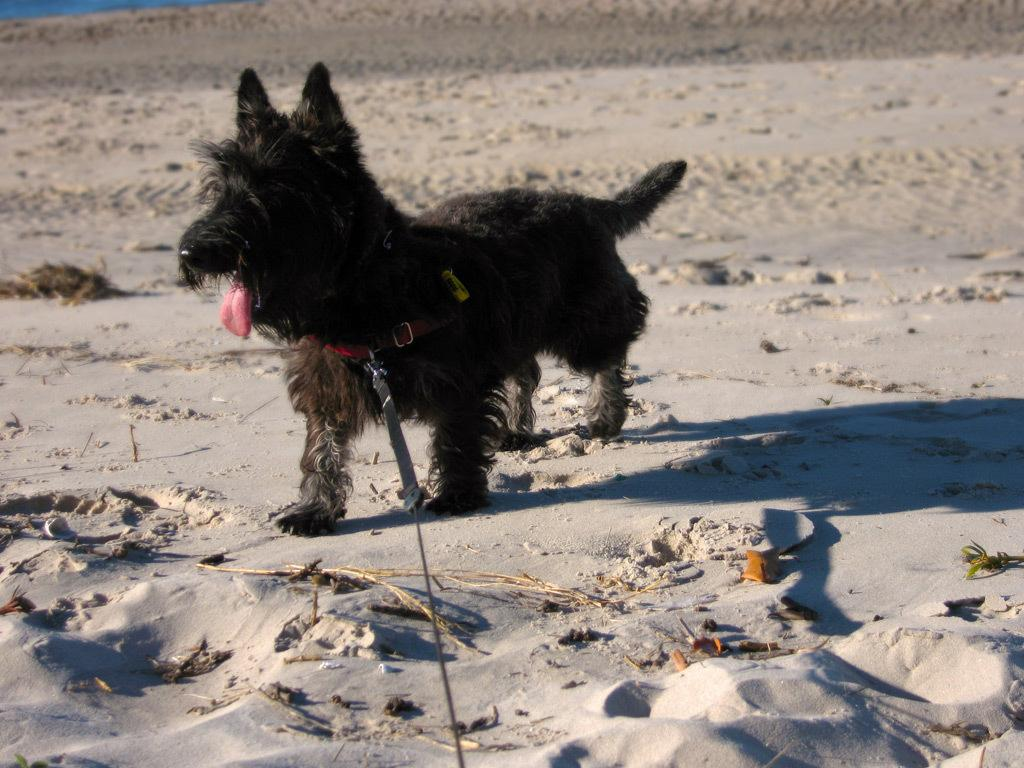What type of animal is in the image? There is a dog in the image. What is around the dog's neck? The dog has a neck band. How is the dog connected to the ground? The dog has a leash, and both the leash and neck band are on the ground. What type of music can be heard coming from the camp in the image? There is no camp or music present in the image; it features a dog with a neck band and leash. 